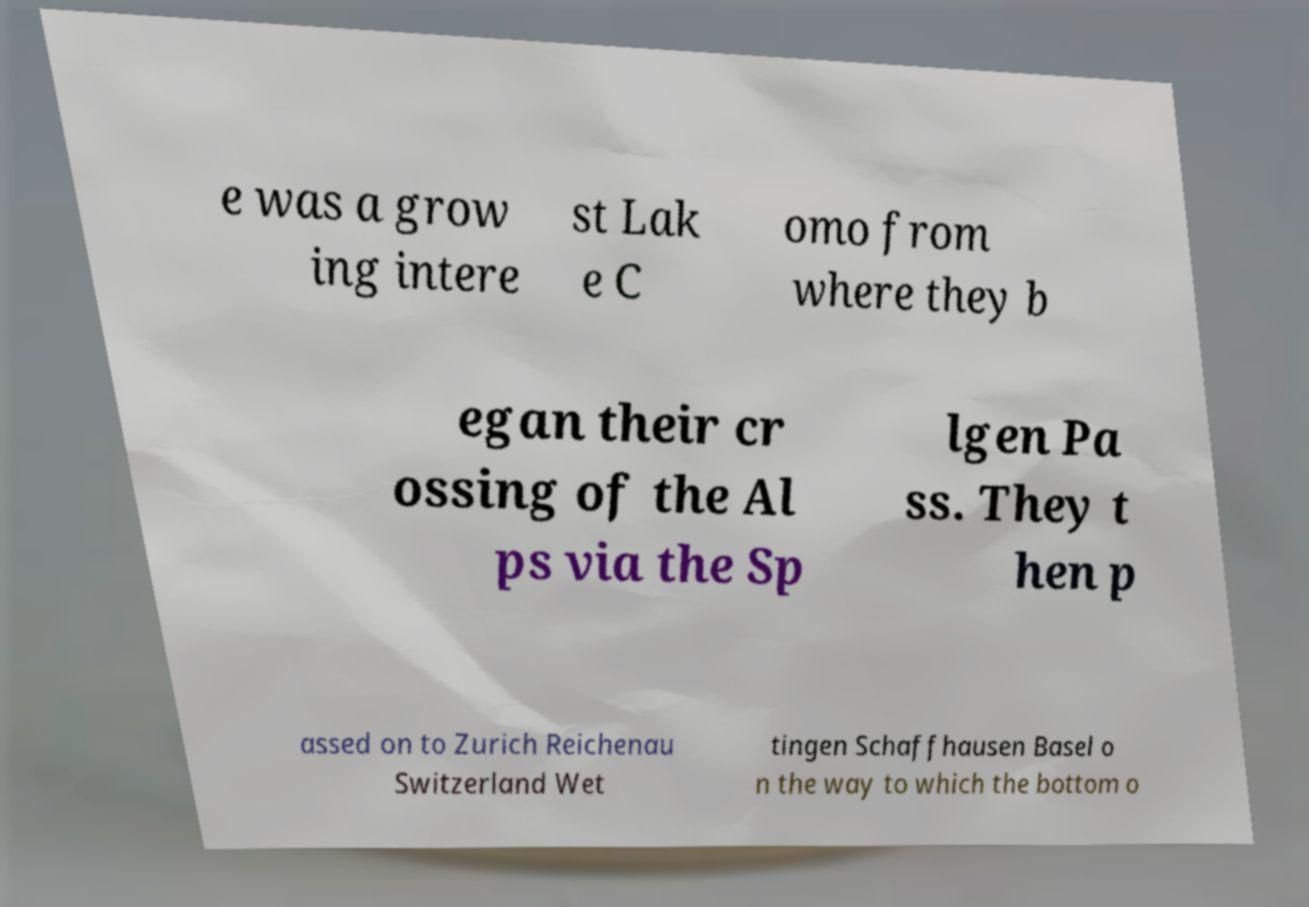Could you extract and type out the text from this image? e was a grow ing intere st Lak e C omo from where they b egan their cr ossing of the Al ps via the Sp lgen Pa ss. They t hen p assed on to Zurich Reichenau Switzerland Wet tingen Schaffhausen Basel o n the way to which the bottom o 